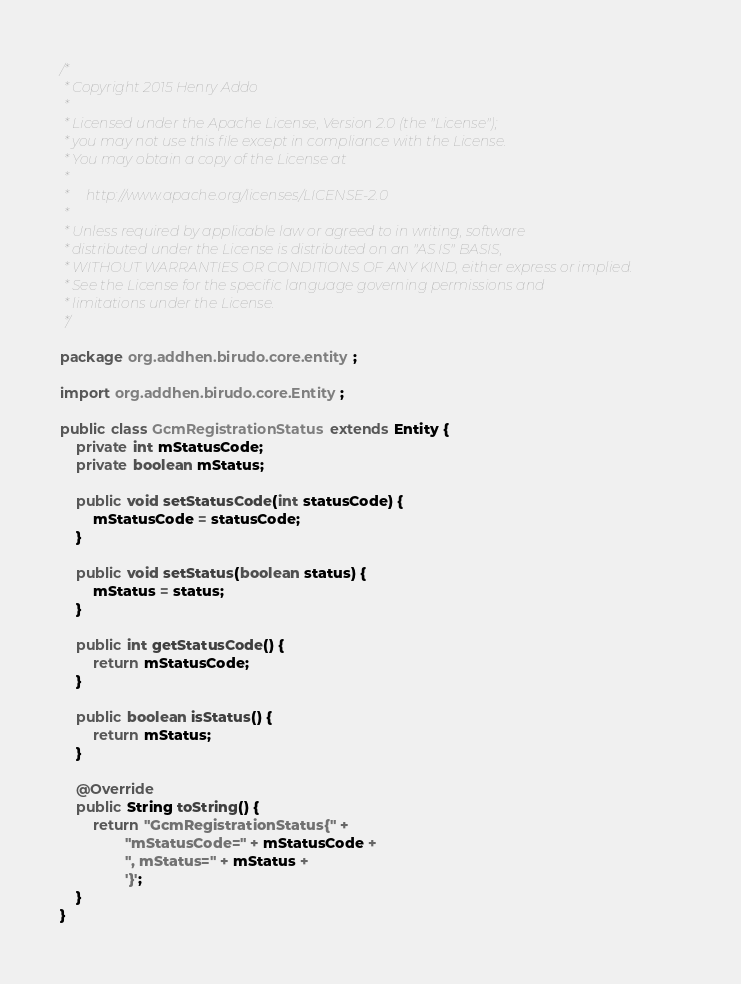<code> <loc_0><loc_0><loc_500><loc_500><_Java_>/*
 * Copyright 2015 Henry Addo
 *
 * Licensed under the Apache License, Version 2.0 (the "License");
 * you may not use this file except in compliance with the License.
 * You may obtain a copy of the License at
 *
 *     http://www.apache.org/licenses/LICENSE-2.0
 *
 * Unless required by applicable law or agreed to in writing, software
 * distributed under the License is distributed on an "AS IS" BASIS,
 * WITHOUT WARRANTIES OR CONDITIONS OF ANY KIND, either express or implied.
 * See the License for the specific language governing permissions and
 * limitations under the License.
 */

package org.addhen.birudo.core.entity;

import org.addhen.birudo.core.Entity;

public class GcmRegistrationStatus extends Entity {
    private int mStatusCode;
    private boolean mStatus;

    public void setStatusCode(int statusCode) {
        mStatusCode = statusCode;
    }

    public void setStatus(boolean status) {
        mStatus = status;
    }

    public int getStatusCode() {
        return mStatusCode;
    }

    public boolean isStatus() {
        return mStatus;
    }

    @Override
    public String toString() {
        return "GcmRegistrationStatus{" +
                "mStatusCode=" + mStatusCode +
                ", mStatus=" + mStatus +
                '}';
    }
}
</code> 